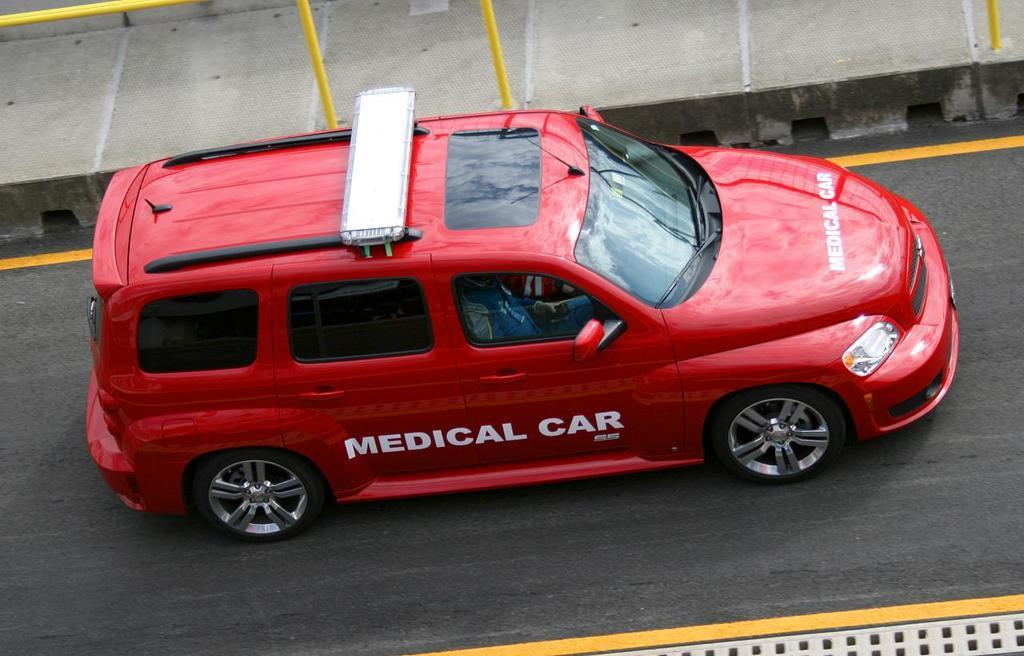What is the person in the image doing? There is a person sitting in a car in the image. Where is the car located? The car is on the road in the image. What can be seen on the pathway at the top of the image? There are iron rods on a pathway at the top of the image. What is the price of the ear in the image? There is no ear present in the image, so it is not possible to determine its price. 